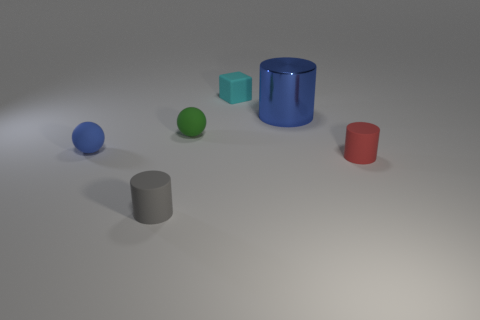Subtract all purple cylinders. Subtract all red spheres. How many cylinders are left? 3 Add 4 cyan rubber things. How many objects exist? 10 Subtract all blocks. How many objects are left? 5 Add 3 large cyan rubber cylinders. How many large cyan rubber cylinders exist? 3 Subtract 0 gray balls. How many objects are left? 6 Subtract all purple rubber objects. Subtract all small red rubber things. How many objects are left? 5 Add 4 big blue objects. How many big blue objects are left? 5 